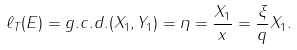Convert formula to latex. <formula><loc_0><loc_0><loc_500><loc_500>\ell _ { T } ( E ) = g . c . d . ( X _ { 1 } , Y _ { 1 } ) = \eta = \frac { X _ { 1 } } { x } = \frac { \xi } { q } X _ { 1 } .</formula> 